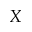<formula> <loc_0><loc_0><loc_500><loc_500>X</formula> 